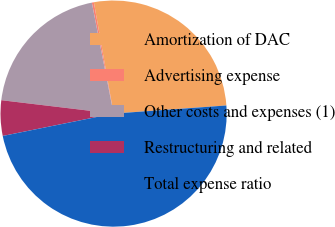Convert chart to OTSL. <chart><loc_0><loc_0><loc_500><loc_500><pie_chart><fcel>Amortization of DAC<fcel>Advertising expense<fcel>Other costs and expenses (1)<fcel>Restructuring and related<fcel>Total expense ratio<nl><fcel>26.65%<fcel>0.29%<fcel>20.03%<fcel>5.06%<fcel>47.98%<nl></chart> 